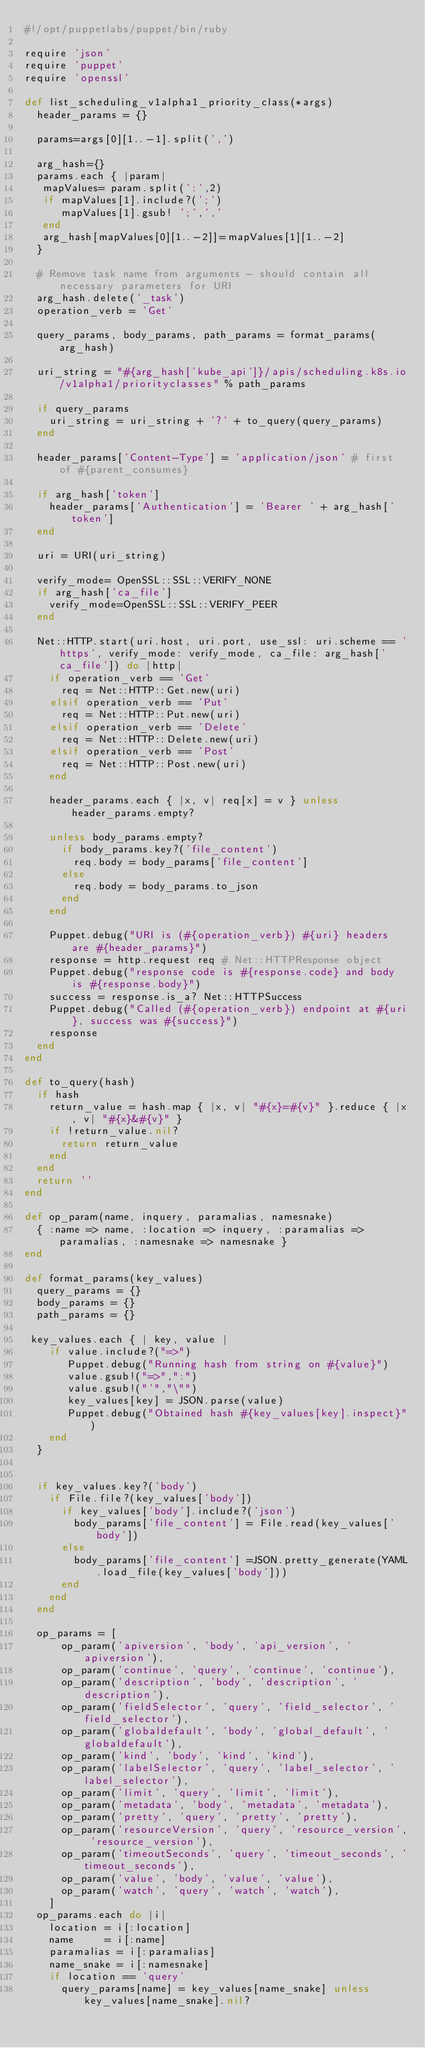Convert code to text. <code><loc_0><loc_0><loc_500><loc_500><_Ruby_>#!/opt/puppetlabs/puppet/bin/ruby

require 'json'
require 'puppet'
require 'openssl'

def list_scheduling_v1alpha1_priority_class(*args)
  header_params = {}
  
  params=args[0][1..-1].split(',')

  arg_hash={}
  params.each { |param|
   mapValues= param.split(':',2)
   if mapValues[1].include?(';')
      mapValues[1].gsub! ';',','
   end
   arg_hash[mapValues[0][1..-2]]=mapValues[1][1..-2]
  }

  # Remove task name from arguments - should contain all necessary parameters for URI
  arg_hash.delete('_task')
  operation_verb = 'Get'

  query_params, body_params, path_params = format_params(arg_hash)

  uri_string = "#{arg_hash['kube_api']}/apis/scheduling.k8s.io/v1alpha1/priorityclasses" % path_params

  if query_params
    uri_string = uri_string + '?' + to_query(query_params)
  end

  header_params['Content-Type'] = 'application/json' # first of #{parent_consumes}

  if arg_hash['token']
    header_params['Authentication'] = 'Bearer ' + arg_hash['token']
  end

  uri = URI(uri_string)
 
  verify_mode= OpenSSL::SSL::VERIFY_NONE
  if arg_hash['ca_file']
    verify_mode=OpenSSL::SSL::VERIFY_PEER
  end

  Net::HTTP.start(uri.host, uri.port, use_ssl: uri.scheme == 'https', verify_mode: verify_mode, ca_file: arg_hash['ca_file']) do |http|
    if operation_verb == 'Get'
      req = Net::HTTP::Get.new(uri)
    elsif operation_verb == 'Put'
      req = Net::HTTP::Put.new(uri)
    elsif operation_verb == 'Delete'
      req = Net::HTTP::Delete.new(uri)
    elsif operation_verb == 'Post'
      req = Net::HTTP::Post.new(uri)
    end

    header_params.each { |x, v| req[x] = v } unless header_params.empty?

    unless body_params.empty?
      if body_params.key?('file_content')
        req.body = body_params['file_content']
      else
        req.body = body_params.to_json
      end
    end

    Puppet.debug("URI is (#{operation_verb}) #{uri} headers are #{header_params}")
    response = http.request req # Net::HTTPResponse object
    Puppet.debug("response code is #{response.code} and body is #{response.body}")
    success = response.is_a? Net::HTTPSuccess
    Puppet.debug("Called (#{operation_verb}) endpoint at #{uri}, success was #{success}")
    response
  end
end

def to_query(hash)
  if hash
    return_value = hash.map { |x, v| "#{x}=#{v}" }.reduce { |x, v| "#{x}&#{v}" }
    if !return_value.nil?
      return return_value
    end
  end
  return ''
end

def op_param(name, inquery, paramalias, namesnake)
  { :name => name, :location => inquery, :paramalias => paramalias, :namesnake => namesnake }
end

def format_params(key_values)
  query_params = {}
  body_params = {}
  path_params = {}

 key_values.each { | key, value |
    if value.include?("=>")
       Puppet.debug("Running hash from string on #{value}")
       value.gsub!("=>",":")
       value.gsub!("'","\"")
       key_values[key] = JSON.parse(value)
       Puppet.debug("Obtained hash #{key_values[key].inspect}")
    end
  }


  if key_values.key?('body')
    if File.file?(key_values['body'])
      if key_values['body'].include?('json')
        body_params['file_content'] = File.read(key_values['body'])
      else
        body_params['file_content'] =JSON.pretty_generate(YAML.load_file(key_values['body']))
      end
    end
  end

  op_params = [
      op_param('apiversion', 'body', 'api_version', 'apiversion'),
      op_param('continue', 'query', 'continue', 'continue'),
      op_param('description', 'body', 'description', 'description'),
      op_param('fieldSelector', 'query', 'field_selector', 'field_selector'),
      op_param('globaldefault', 'body', 'global_default', 'globaldefault'),
      op_param('kind', 'body', 'kind', 'kind'),
      op_param('labelSelector', 'query', 'label_selector', 'label_selector'),
      op_param('limit', 'query', 'limit', 'limit'),
      op_param('metadata', 'body', 'metadata', 'metadata'),
      op_param('pretty', 'query', 'pretty', 'pretty'),
      op_param('resourceVersion', 'query', 'resource_version', 'resource_version'),
      op_param('timeoutSeconds', 'query', 'timeout_seconds', 'timeout_seconds'),
      op_param('value', 'body', 'value', 'value'),
      op_param('watch', 'query', 'watch', 'watch'),
    ]
  op_params.each do |i|
    location = i[:location]
    name     = i[:name]
    paramalias = i[:paramalias]
    name_snake = i[:namesnake]
    if location == 'query'
      query_params[name] = key_values[name_snake] unless key_values[name_snake].nil?</code> 